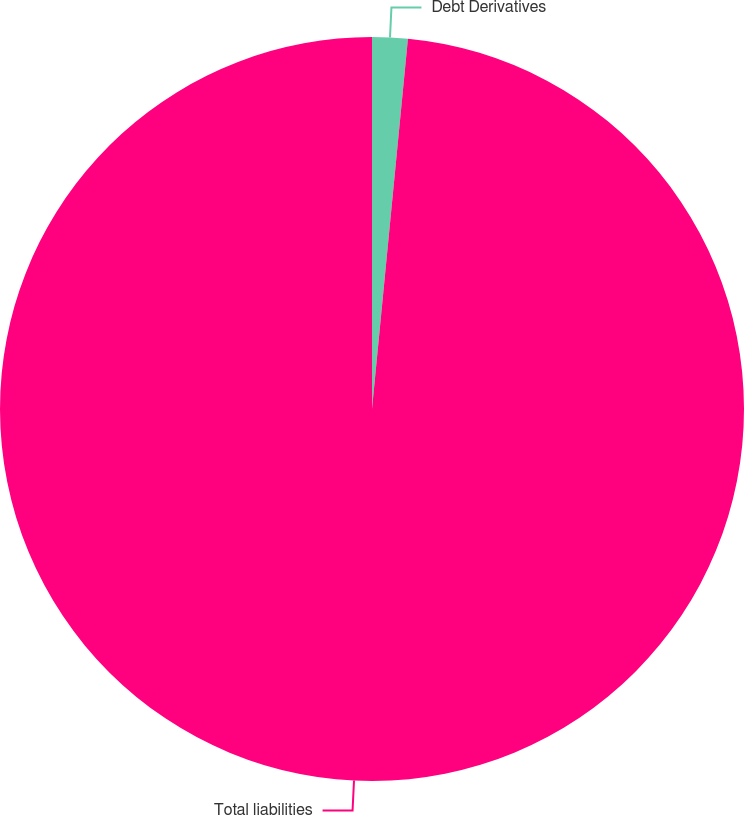<chart> <loc_0><loc_0><loc_500><loc_500><pie_chart><fcel>Debt Derivatives<fcel>Total liabilities<nl><fcel>1.54%<fcel>98.46%<nl></chart> 